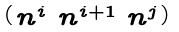<formula> <loc_0><loc_0><loc_500><loc_500>\begin{psmallmatrix} n ^ { i } & n ^ { i + 1 } & n ^ { j } \end{psmallmatrix}</formula> 